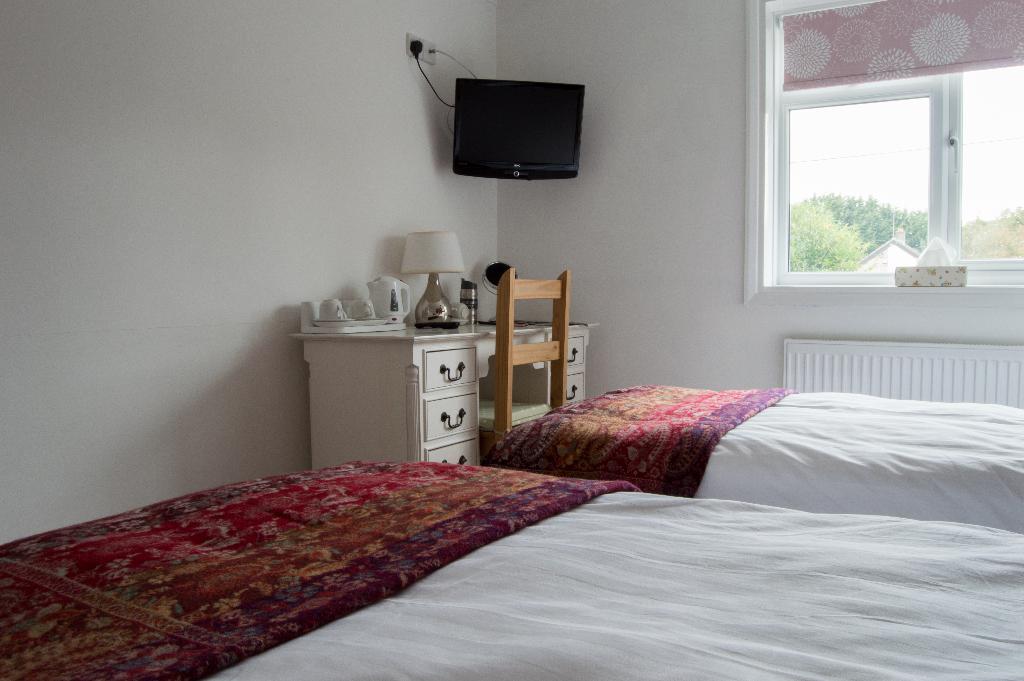Describe this image in one or two sentences. This image is taken in a bedroom. In this image we can see two beds with blankets. We can also see a chair in front of a table and on the table we can see a lamp, bottle, jug, cups and saucers. We can also see a television with a switch board attached to the plain wall. On the right there is a glass window and through the glass window we can see the trees. We can also see the window mat. 